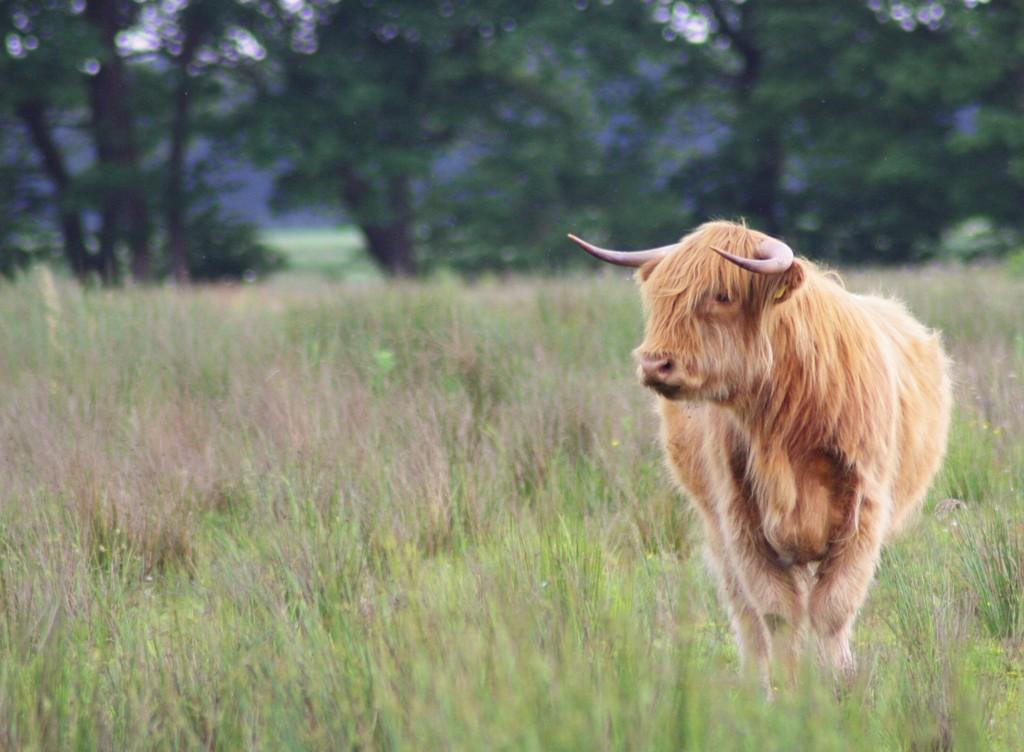What type of animal can be seen in the image? There is an animal in the image, but its specific type cannot be determined from the provided facts. Where is the animal located in the image? The animal is standing at the right side of the image. What can be seen in the background of the image? There are trees and grassland visible in the background of the image. What type of glove is the animal wearing in the image? There is no mention of a glove in the image, and the animal is not wearing any clothing. 